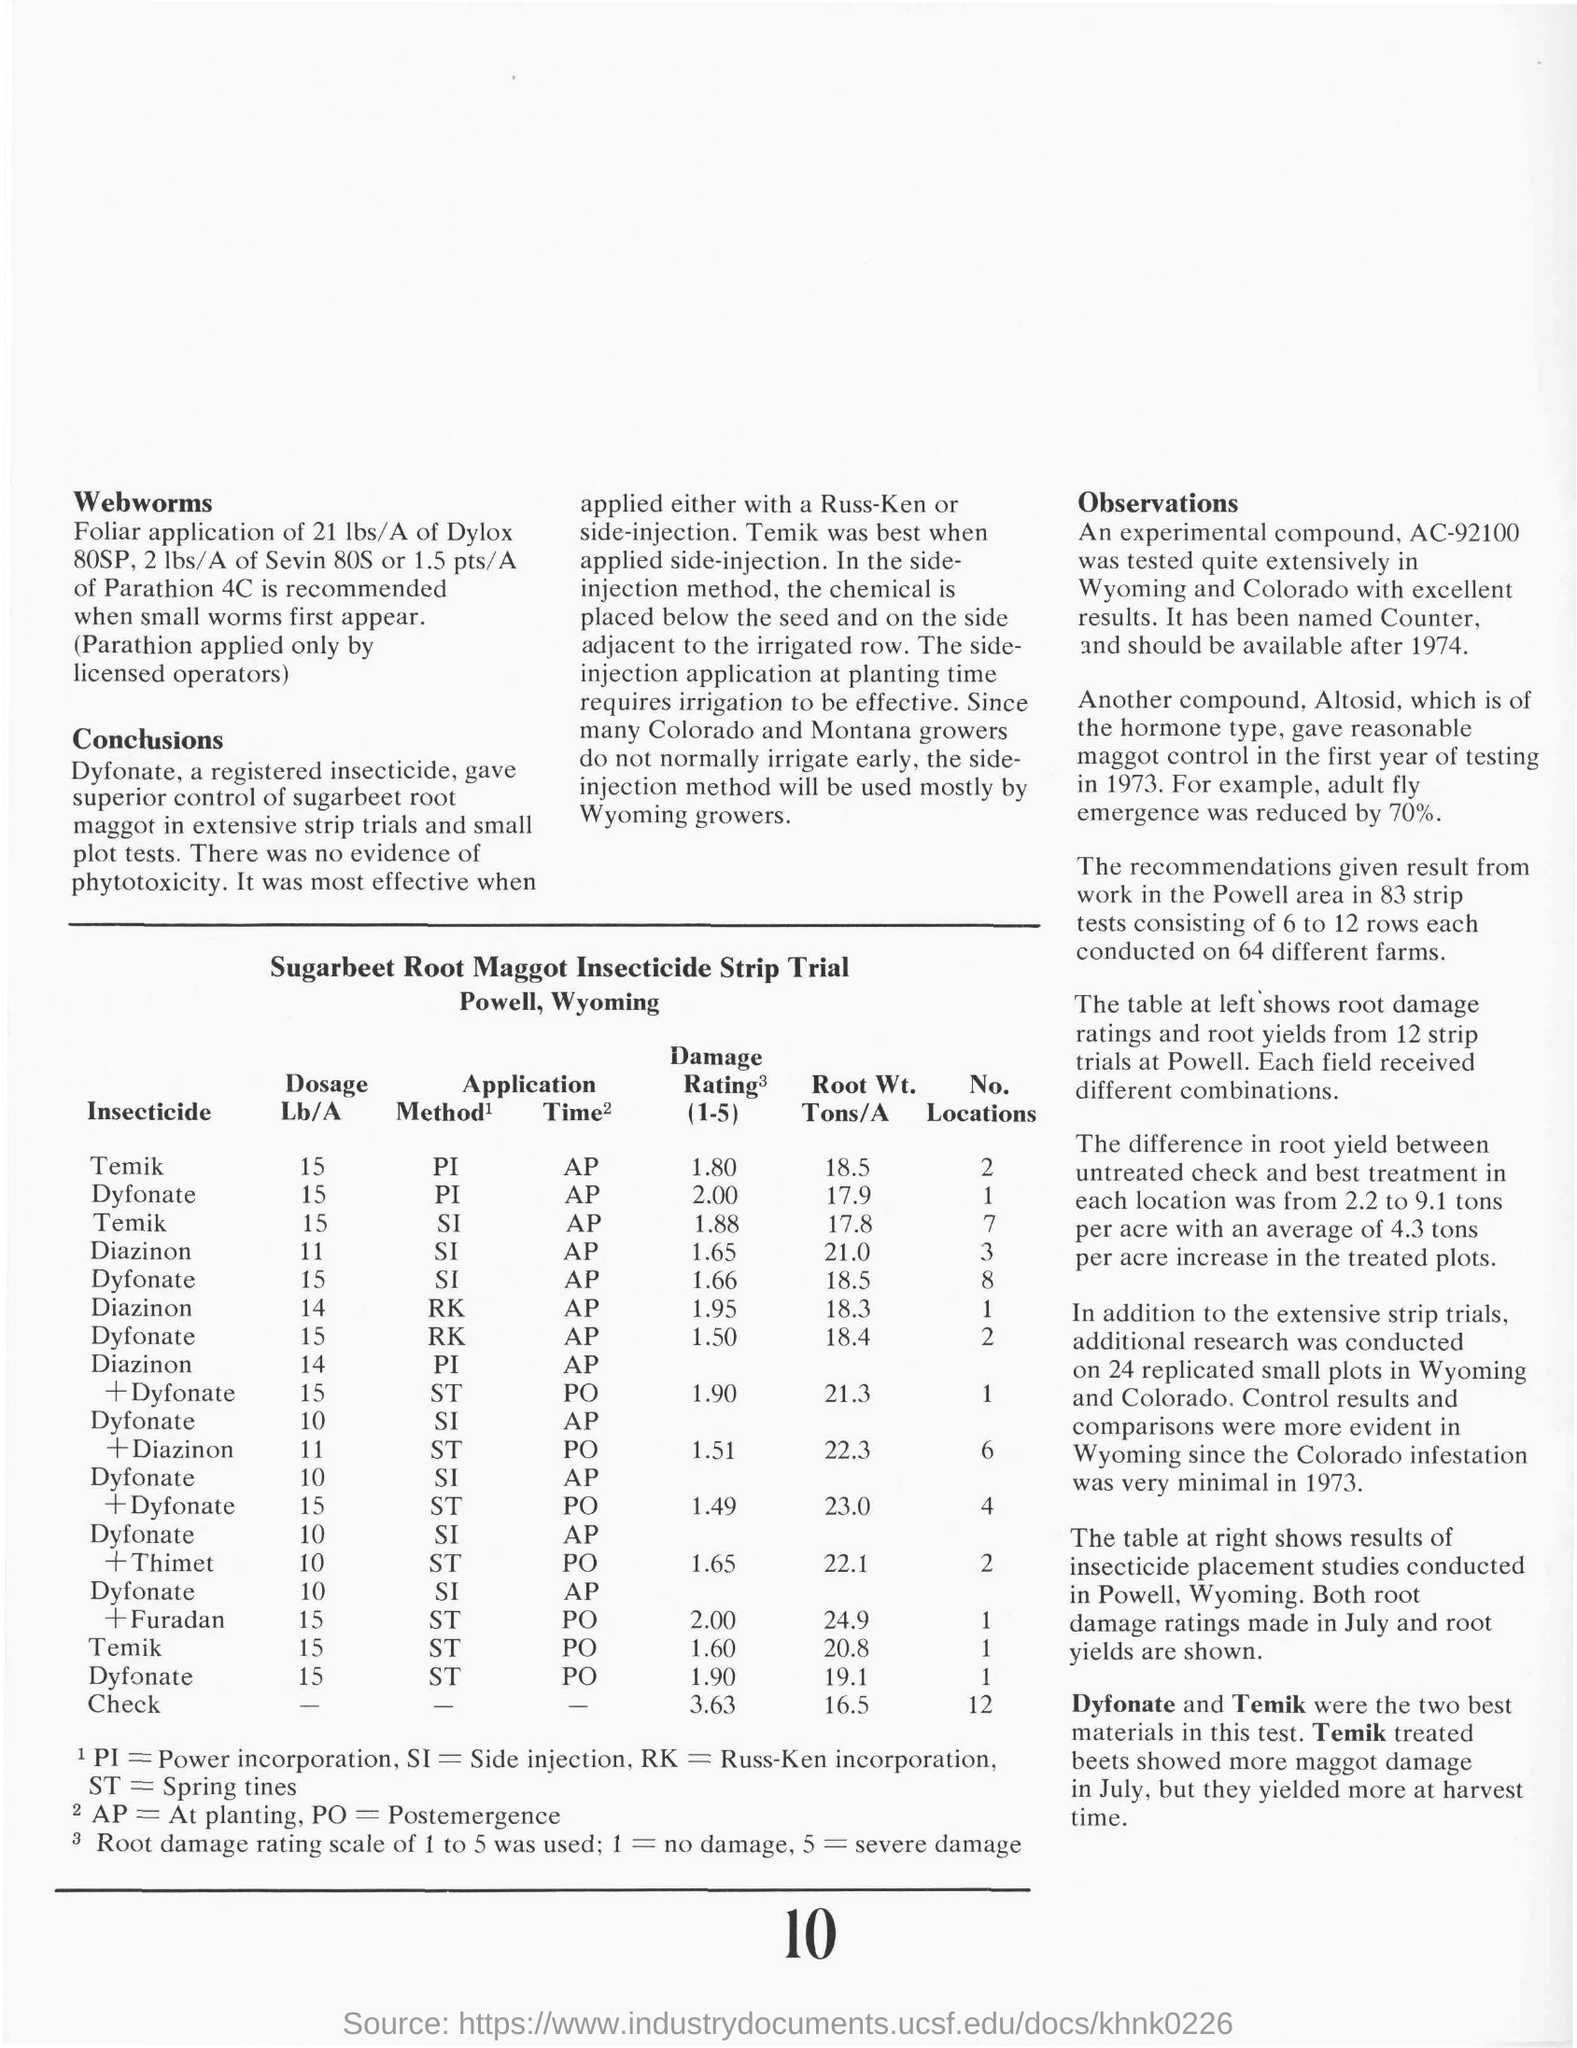Draw attention to some important aspects in this diagram. The two most effective insecticides utilized in the testing were Dyfonate and Temik. According to the information provided, the damage rating observed for a 15 Lb/A dose of Temik applied using the PI method was 1.80. The recommended dosage of Temik used for the soil-integrated (SI) method at planting time is 15 pounds per acre, with the option to increase up to 15 pounds per acre for additional weed control. The trial is for insecticide strips used on sugarbeet roots to control maggot infestations. The dosage of Dyfonate used for PI (Phase-In) method at planting time is 15... 